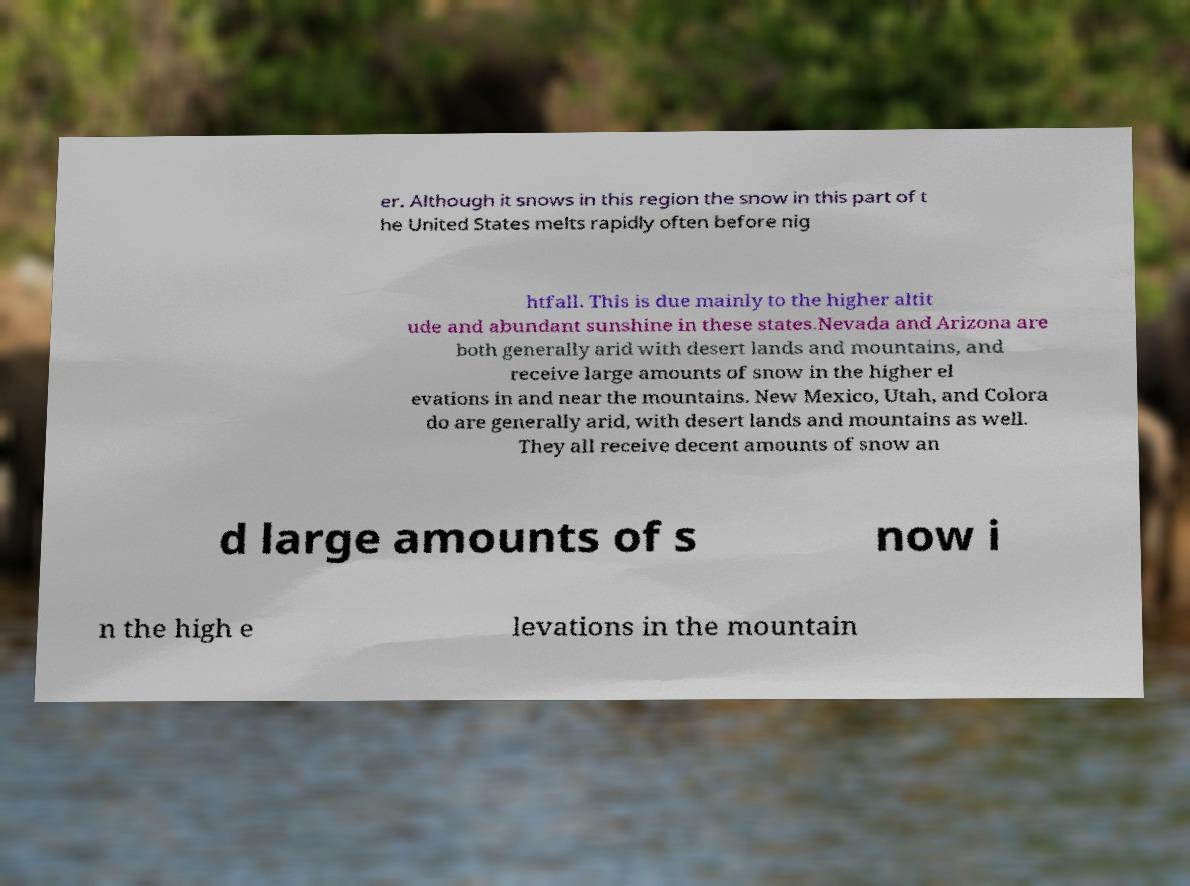There's text embedded in this image that I need extracted. Can you transcribe it verbatim? er. Although it snows in this region the snow in this part of t he United States melts rapidly often before nig htfall. This is due mainly to the higher altit ude and abundant sunshine in these states.Nevada and Arizona are both generally arid with desert lands and mountains, and receive large amounts of snow in the higher el evations in and near the mountains. New Mexico, Utah, and Colora do are generally arid, with desert lands and mountains as well. They all receive decent amounts of snow an d large amounts of s now i n the high e levations in the mountain 